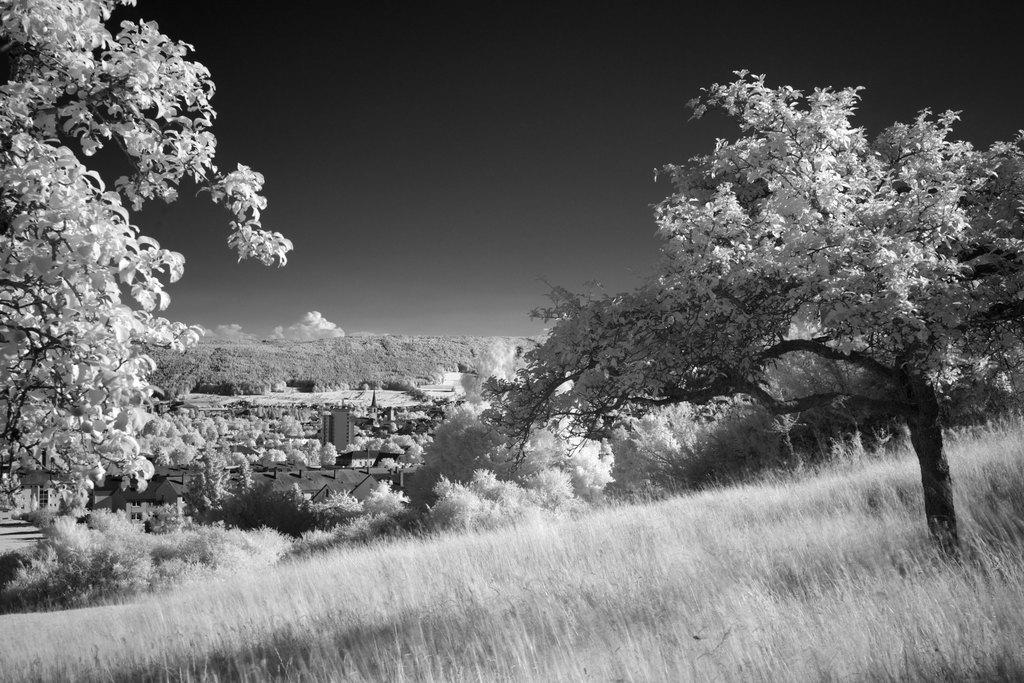What type of vegetation is at the bottom of the image? There is grass at the bottom of the image. What can be seen in the middle of the image? There are trees in the middle of the image. What is visible in the background of the image? The sky is visible in the background of the image. How many spiders are crawling on the trees in the image? There are no spiders visible in the image; it only features grass, trees, and the sky. What is the relationship between the grandfather and the brother in the image? There is no mention of a grandfather or a brother in the image, as it only contains natural elements like grass, trees, and the sky. 